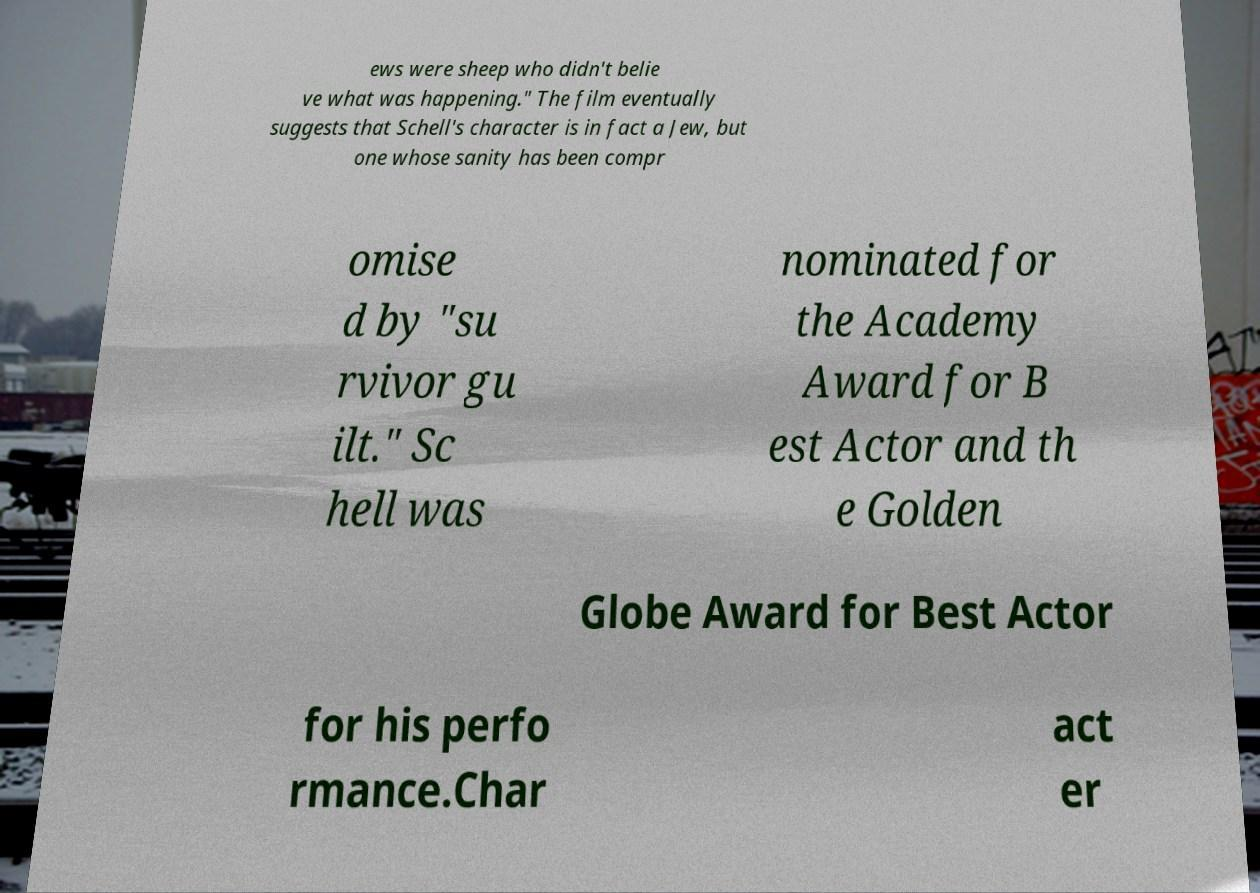I need the written content from this picture converted into text. Can you do that? ews were sheep who didn't belie ve what was happening." The film eventually suggests that Schell's character is in fact a Jew, but one whose sanity has been compr omise d by "su rvivor gu ilt." Sc hell was nominated for the Academy Award for B est Actor and th e Golden Globe Award for Best Actor for his perfo rmance.Char act er 